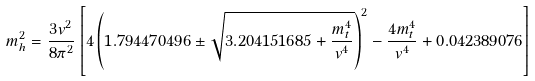<formula> <loc_0><loc_0><loc_500><loc_500>m _ { h } ^ { 2 } = \frac { 3 v ^ { 2 } } { 8 \pi ^ { 2 } } \left [ 4 \left ( 1 . 7 9 4 4 7 0 4 9 6 \pm \sqrt { 3 . 2 0 4 1 5 1 6 8 5 + \frac { m _ { t } ^ { 4 } } { v ^ { 4 } } } \right ) ^ { 2 } - \frac { 4 m _ { t } ^ { 4 } } { v ^ { 4 } } + 0 . 0 4 2 3 8 9 0 7 6 \right ]</formula> 